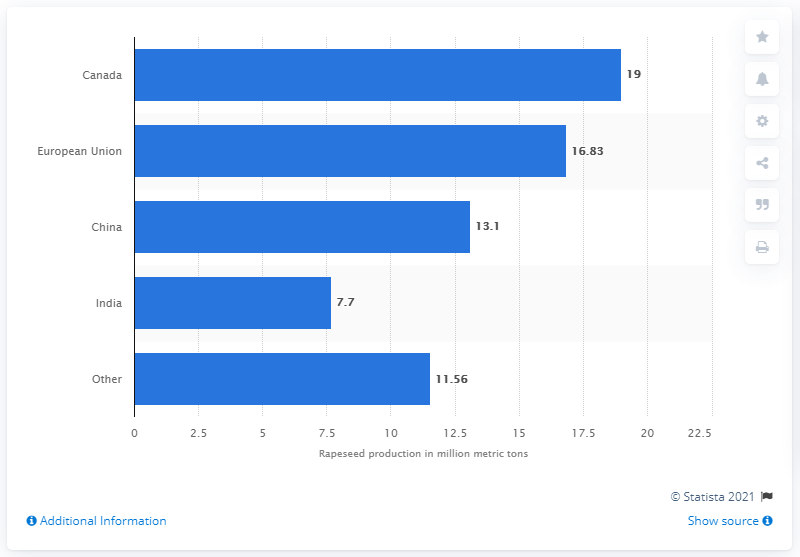List a handful of essential elements in this visual. In the 2019/2020 crop year, Canada was the leading producer of rapeseed. The production volume of rapeseed in Canada during the 2019/2020 season was [insert value here]. 